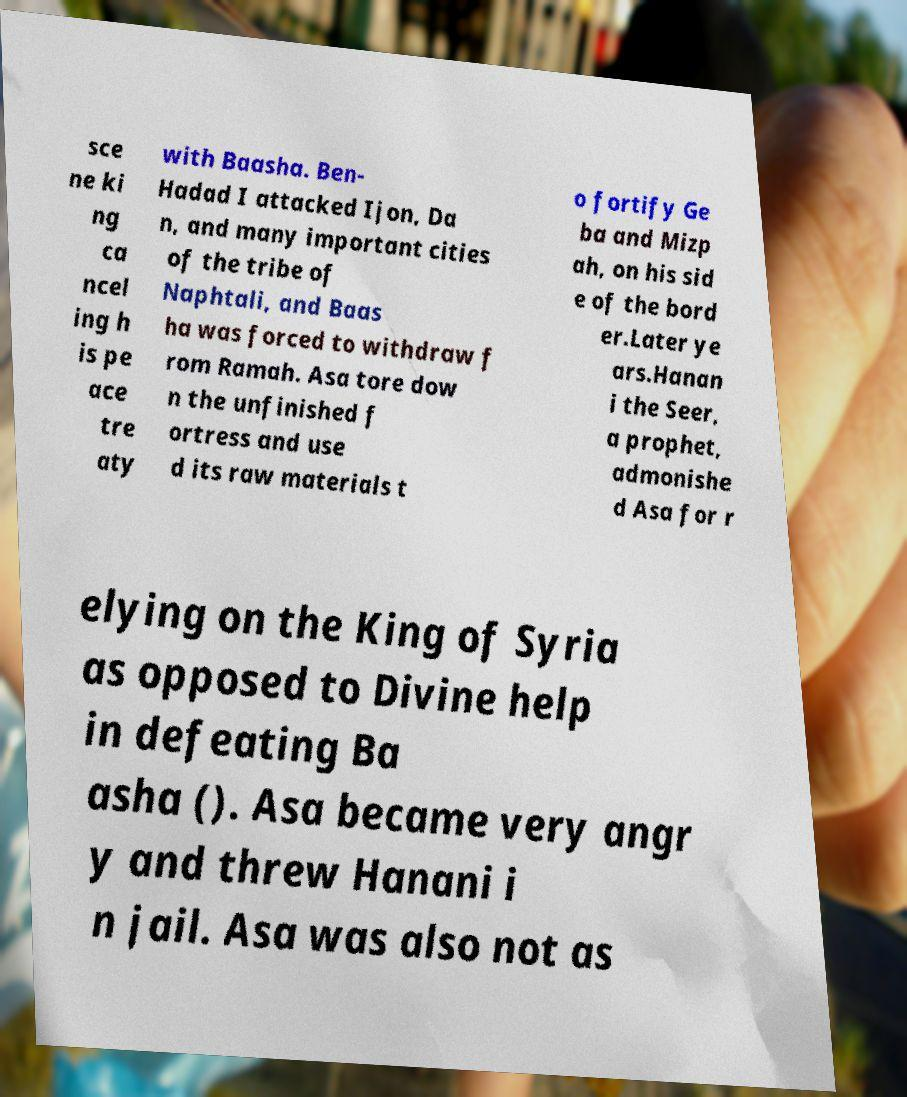Can you read and provide the text displayed in the image?This photo seems to have some interesting text. Can you extract and type it out for me? sce ne ki ng ca ncel ing h is pe ace tre aty with Baasha. Ben- Hadad I attacked Ijon, Da n, and many important cities of the tribe of Naphtali, and Baas ha was forced to withdraw f rom Ramah. Asa tore dow n the unfinished f ortress and use d its raw materials t o fortify Ge ba and Mizp ah, on his sid e of the bord er.Later ye ars.Hanan i the Seer, a prophet, admonishe d Asa for r elying on the King of Syria as opposed to Divine help in defeating Ba asha (). Asa became very angr y and threw Hanani i n jail. Asa was also not as 